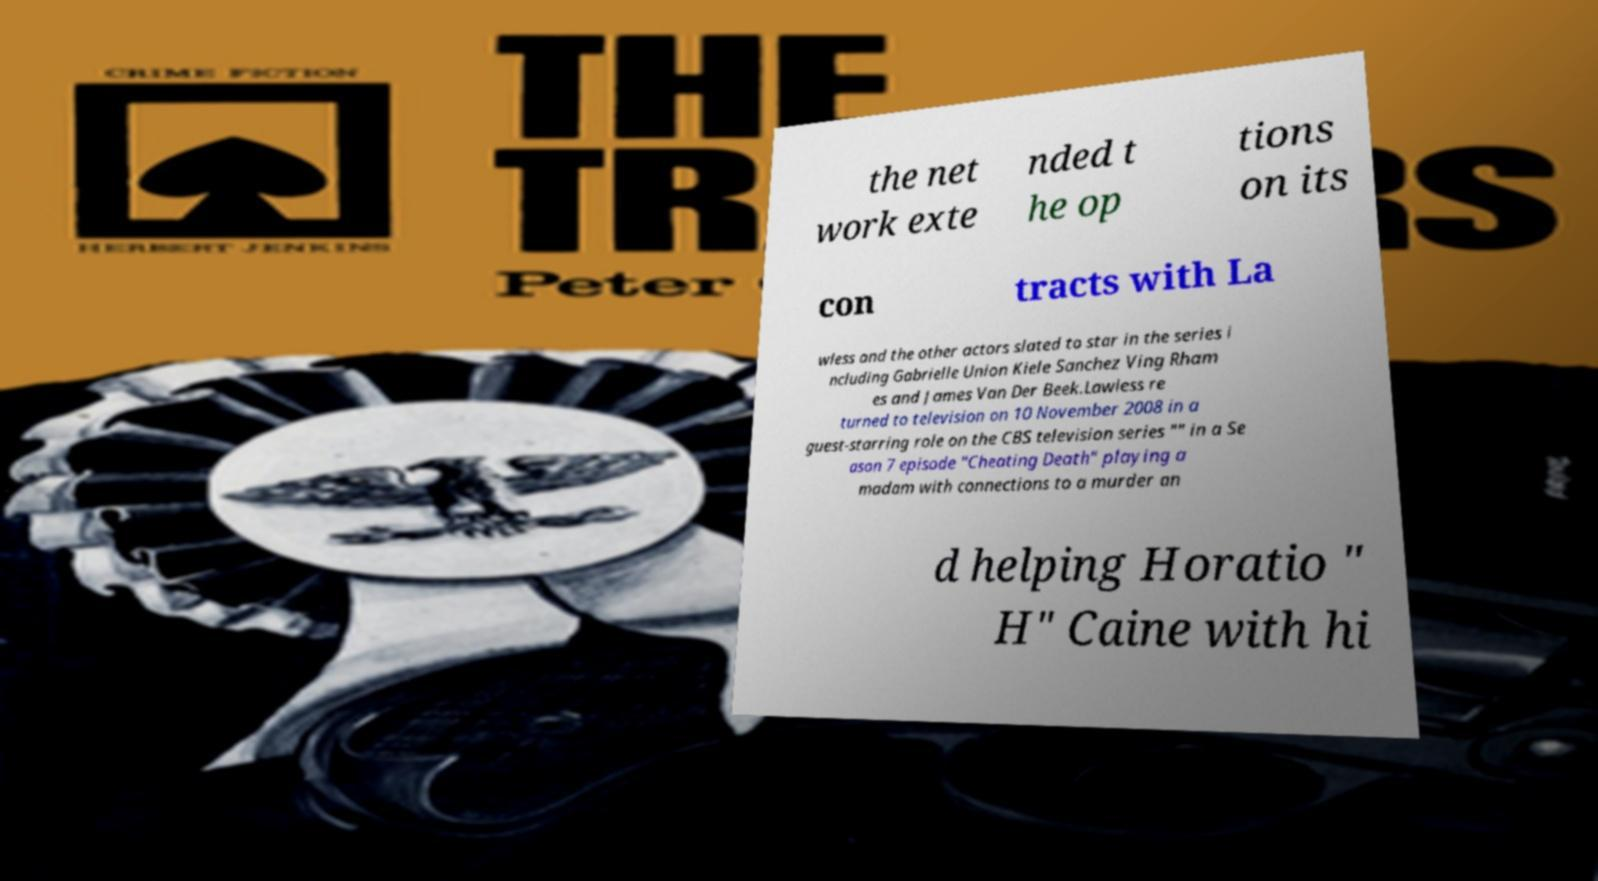There's text embedded in this image that I need extracted. Can you transcribe it verbatim? the net work exte nded t he op tions on its con tracts with La wless and the other actors slated to star in the series i ncluding Gabrielle Union Kiele Sanchez Ving Rham es and James Van Der Beek.Lawless re turned to television on 10 November 2008 in a guest-starring role on the CBS television series "" in a Se ason 7 episode "Cheating Death" playing a madam with connections to a murder an d helping Horatio " H" Caine with hi 